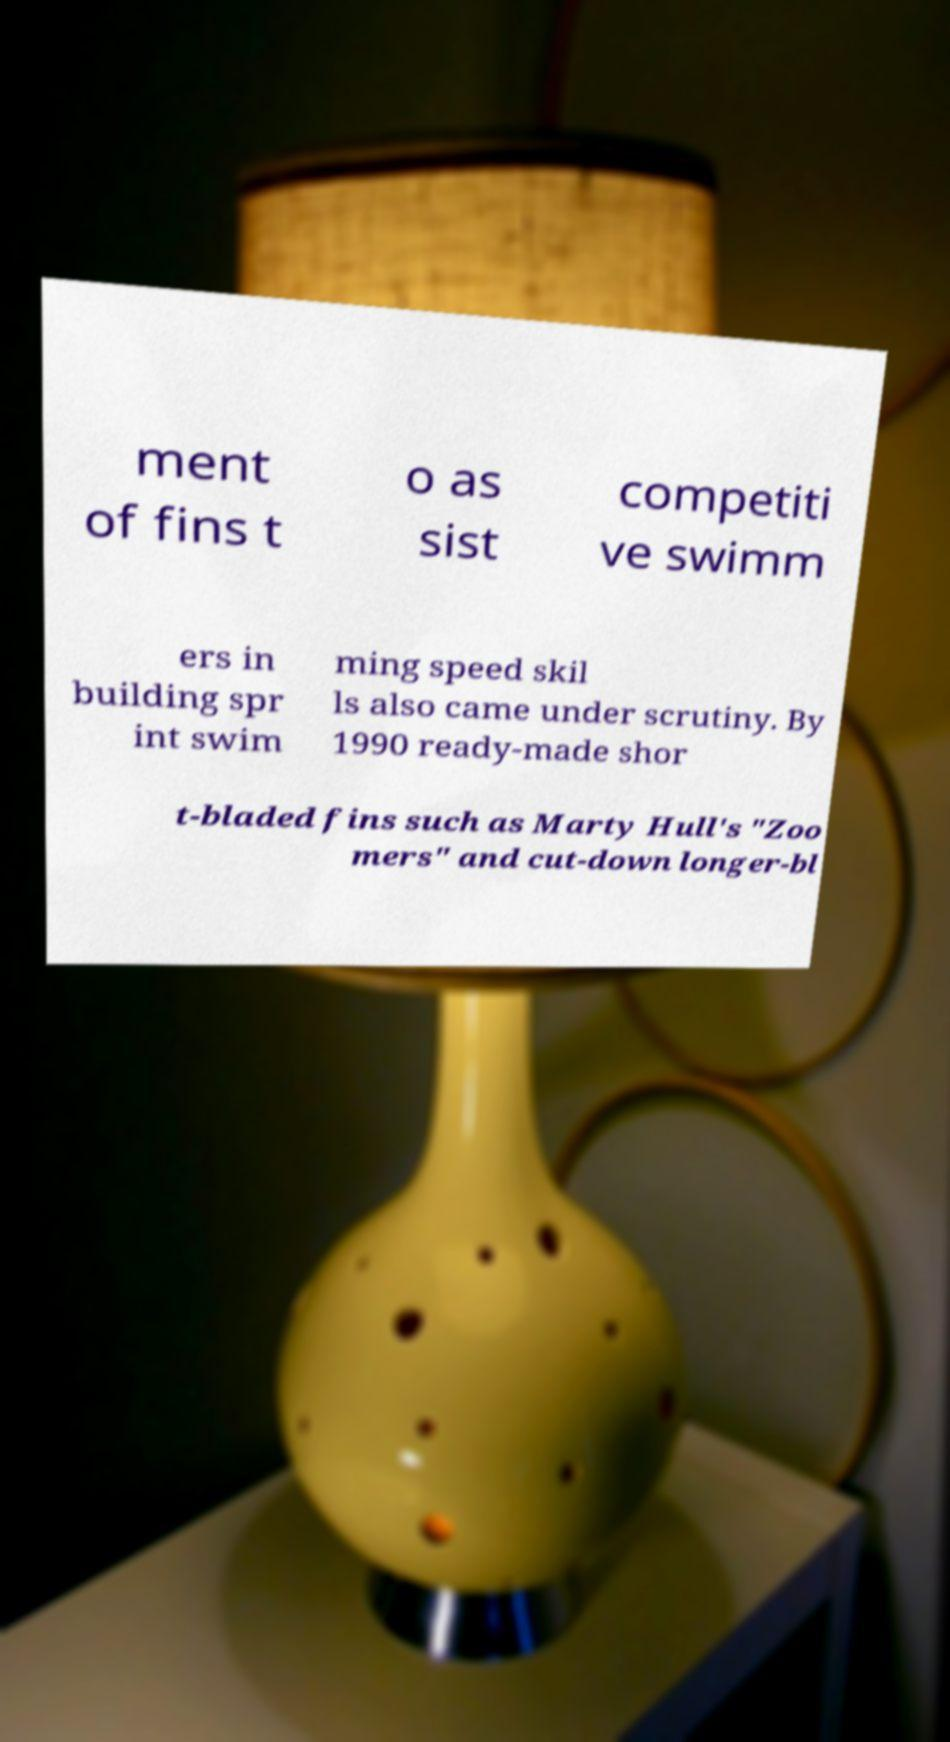Can you read and provide the text displayed in the image?This photo seems to have some interesting text. Can you extract and type it out for me? ment of fins t o as sist competiti ve swimm ers in building spr int swim ming speed skil ls also came under scrutiny. By 1990 ready-made shor t-bladed fins such as Marty Hull's "Zoo mers" and cut-down longer-bl 